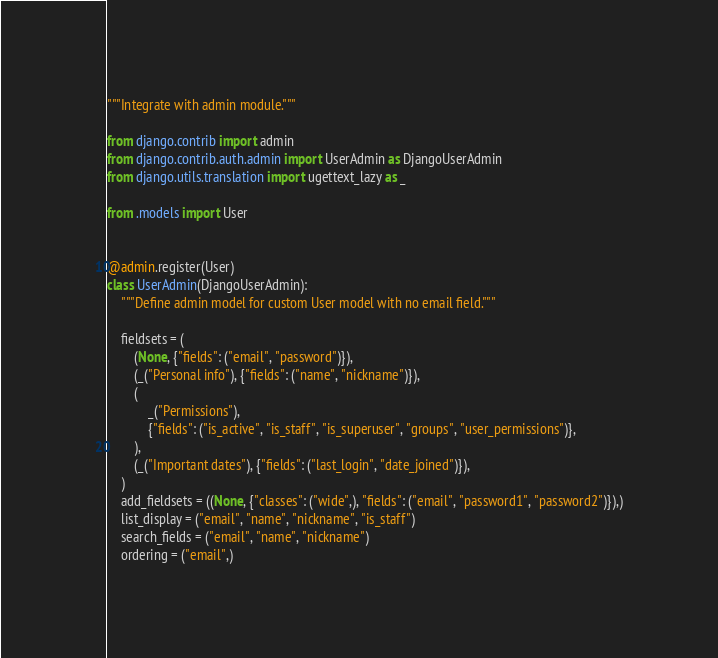Convert code to text. <code><loc_0><loc_0><loc_500><loc_500><_Python_>"""Integrate with admin module."""

from django.contrib import admin
from django.contrib.auth.admin import UserAdmin as DjangoUserAdmin
from django.utils.translation import ugettext_lazy as _

from .models import User


@admin.register(User)
class UserAdmin(DjangoUserAdmin):
    """Define admin model for custom User model with no email field."""

    fieldsets = (
        (None, {"fields": ("email", "password")}),
        (_("Personal info"), {"fields": ("name", "nickname")}),
        (
            _("Permissions"),
            {"fields": ("is_active", "is_staff", "is_superuser", "groups", "user_permissions")},
        ),
        (_("Important dates"), {"fields": ("last_login", "date_joined")}),
    )
    add_fieldsets = ((None, {"classes": ("wide",), "fields": ("email", "password1", "password2")}),)
    list_display = ("email", "name", "nickname", "is_staff")
    search_fields = ("email", "name", "nickname")
    ordering = ("email",)
</code> 